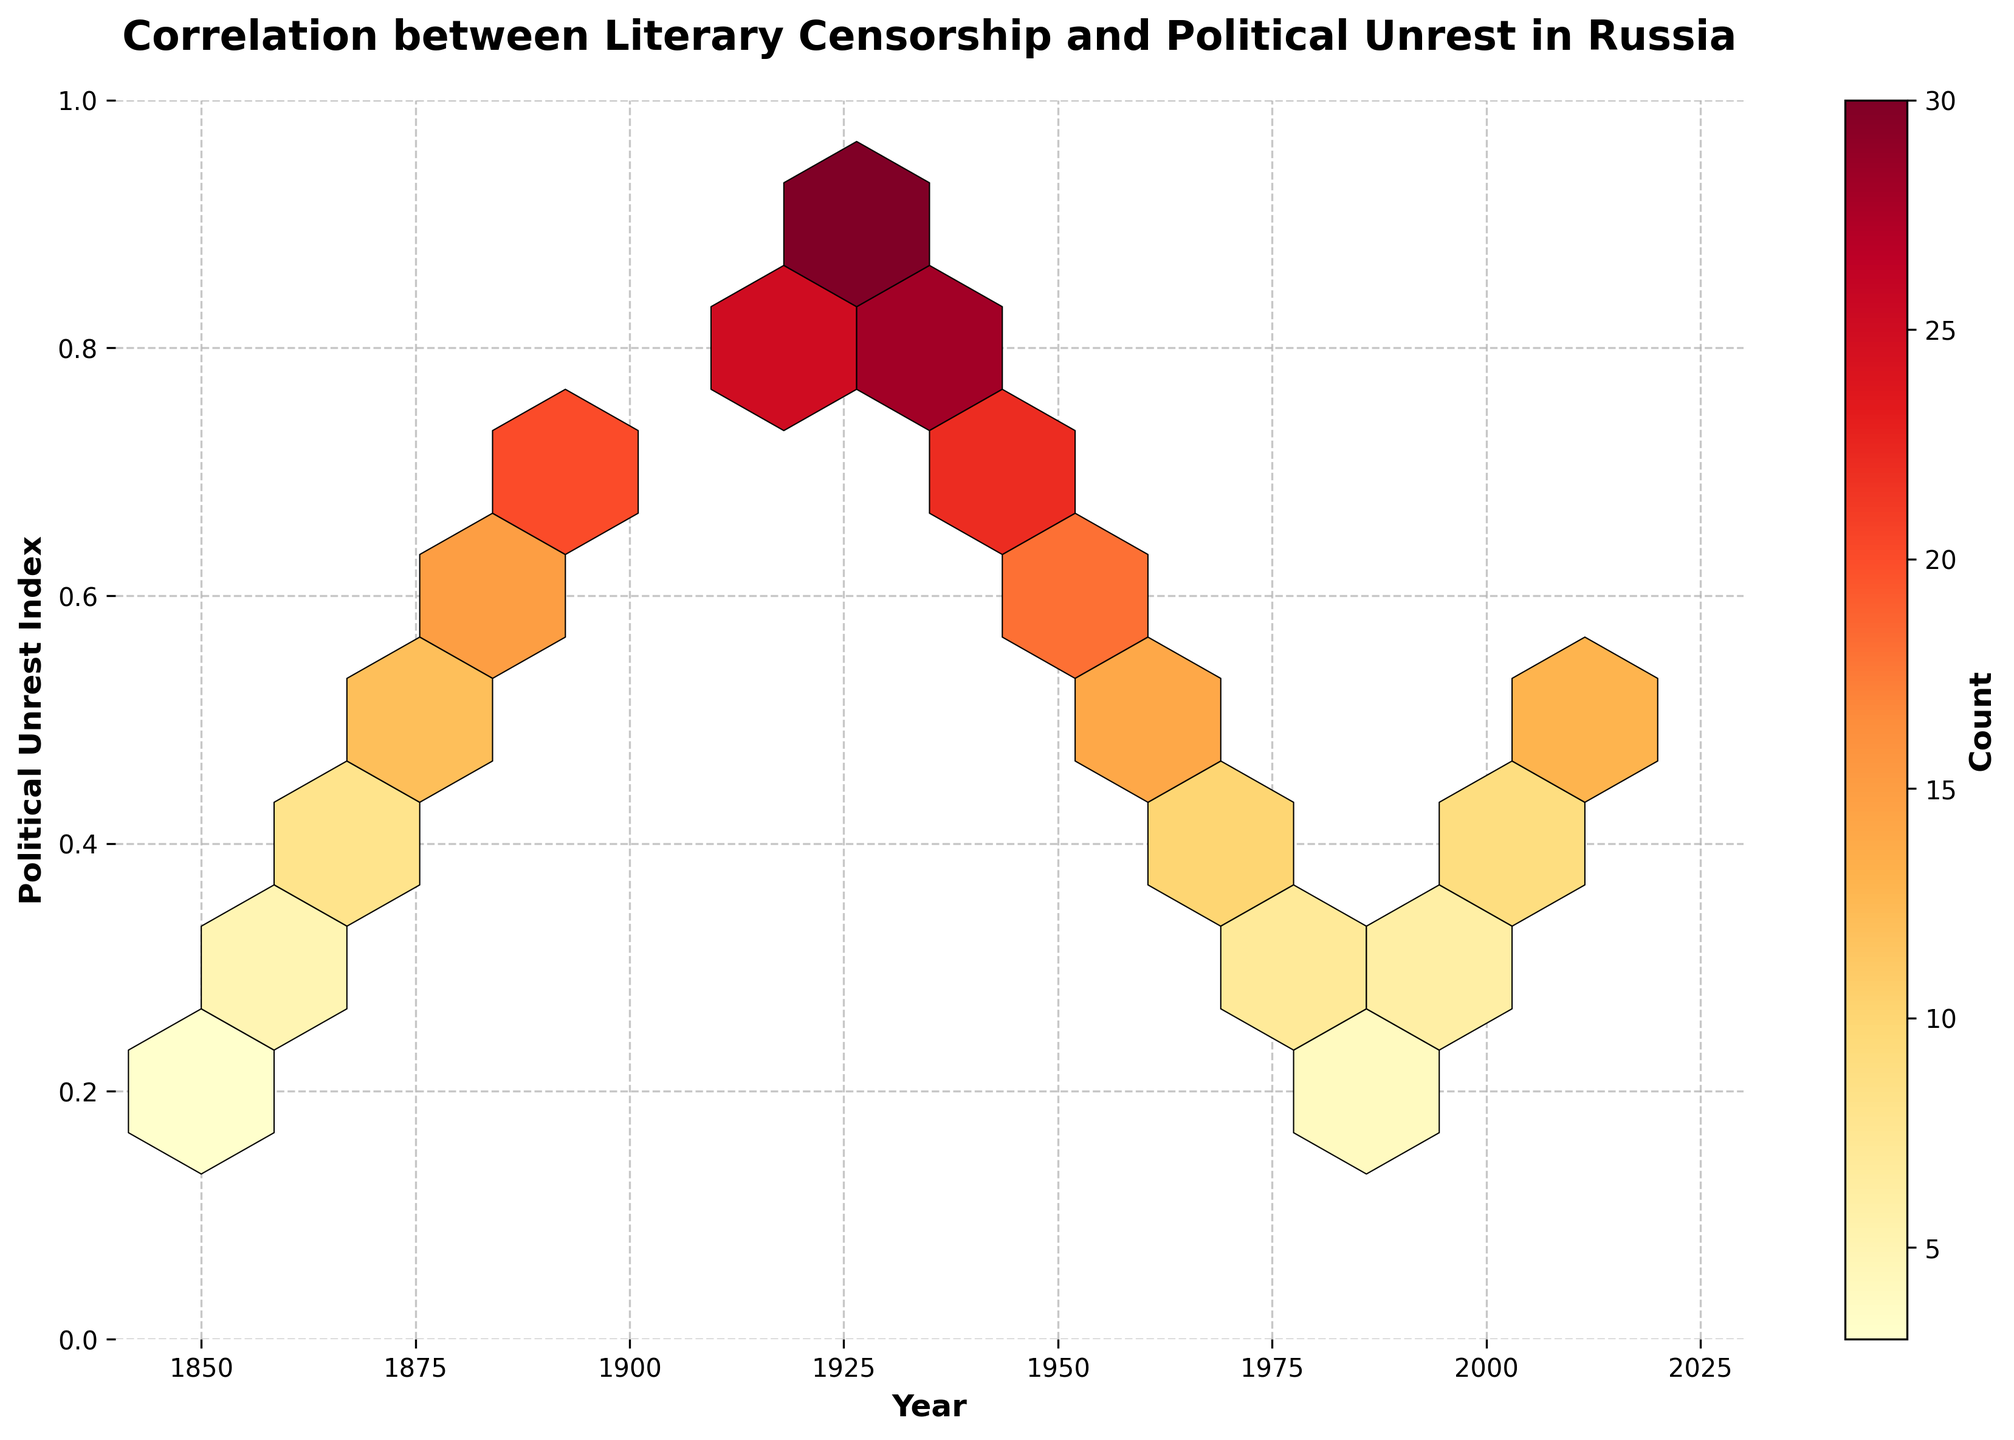What is the title of the plot? The title of the plot is displayed at the top of the figure in a larger and bold font.
Answer: Correlation between Literary Censorship and Political Unrest in Russia What are the x and y-axes labels? The labels of the x and y-axes are written directly below and to the left of the plot area respectively in bold.
Answer: Year, Political Unrest Index What is the range of years shown on the x-axis? The x-axis extends from 1840 to 2030, though the primary data points span from 1850 to 2020.
Answer: 1840 to 2030 How many counts are recorded in the year 1920? Locate the hexbin representing the year 1920 and read the color which maps to its count using the color bar. The data shows 30 counts.
Answer: 30 Which year has the highest political unrest index? The year 1920 has the highest value on the y-axis with a political unrest index of 0.9, as indicated by the y position.
Answer: 1920 What is the x-axis tick where the political unrest index is at its minimum value? The minimum value on the y-axis is 0.2. Locate this value and trace it horizontally to find corresponding x-axis. The data shows it occurs in 1850 and 1990.
Answer: 1850 and 1990 What is the average political unrest index for the years 1960 to 1980? Average is calculated by summing the indices for years 1960, 1970, and 1980, and then dividing by the number of years: (0.5 + 0.4 + 0.3)/3 = 0.4
Answer: 0.4 How does the count change between 1880 and 1910? The count increases from 1880 (12) to 1910 (25) based on the hexagons and color mapping to counts defined in the color bar.
Answer: Increases by 13 Which year shows a decrease in political unrest compared to the previous decade? Compare the political unrest index year over year, noticing political unrest is at 0.9 in 1920 then decreases to 0.8 by 1930.
Answer: 1930 